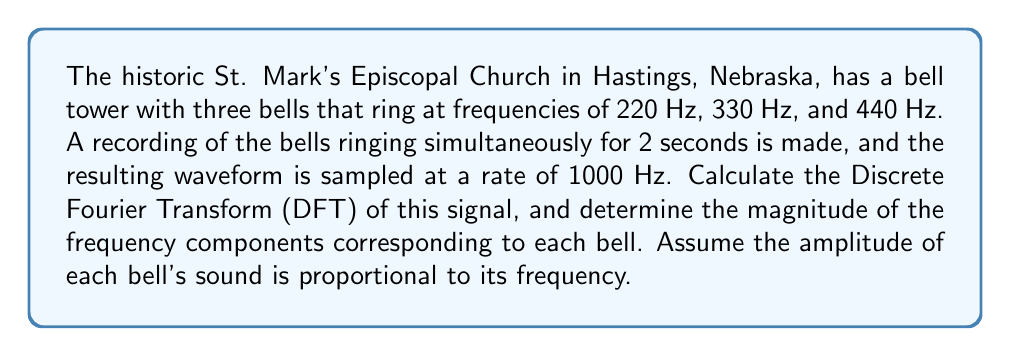Teach me how to tackle this problem. Let's approach this problem step by step:

1) First, we need to understand the parameters:
   - Sampling rate: 1000 Hz
   - Duration: 2 seconds
   - Number of samples: $N = 1000 \text{ Hz} \times 2 \text{ s} = 2000$ samples

2) The Discrete Fourier Transform (DFT) is given by:

   $$X[k] = \sum_{n=0}^{N-1} x[n] e^{-j2\pi kn/N}$$

   where $X[k]$ is the $k$-th frequency component, and $x[n]$ is the $n$-th time sample.

3) The frequency resolution of the DFT is:

   $$\Delta f = \frac{f_s}{N} = \frac{1000 \text{ Hz}}{2000} = 0.5 \text{ Hz}$$

4) The indices $k$ corresponding to our bell frequencies are:
   - 220 Hz: $k_1 = 220 / 0.5 = 440$
   - 330 Hz: $k_2 = 330 / 0.5 = 660$
   - 440 Hz: $k_3 = 440 / 0.5 = 880$

5) The amplitude of each bell's sound is proportional to its frequency. Let's normalize these amplitudes:
   - 220 Hz: $A_1 = 220 / 440 = 0.5$
   - 330 Hz: $A_2 = 330 / 440 = 0.75$
   - 440 Hz: $A_3 = 440 / 440 = 1$

6) The time-domain signal can be represented as:

   $$x(t) = 0.5\sin(2\pi 220t) + 0.75\sin(2\pi 330t) + \sin(2\pi 440t)$$

7) The magnitude of each frequency component in the DFT will be proportional to these amplitudes and the number of samples:

   $$|X[k_i]| = \frac{N}{2} A_i$$

8) Therefore, the magnitudes are:
   - 220 Hz: $|X[440]| = 1000 \times 0.5 = 500$
   - 330 Hz: $|X[660]| = 1000 \times 0.75 = 750$
   - 440 Hz: $|X[880]| = 1000 \times 1 = 1000$
Answer: The magnitudes of the frequency components corresponding to each bell are:
220 Hz: 500
330 Hz: 750
440 Hz: 1000 